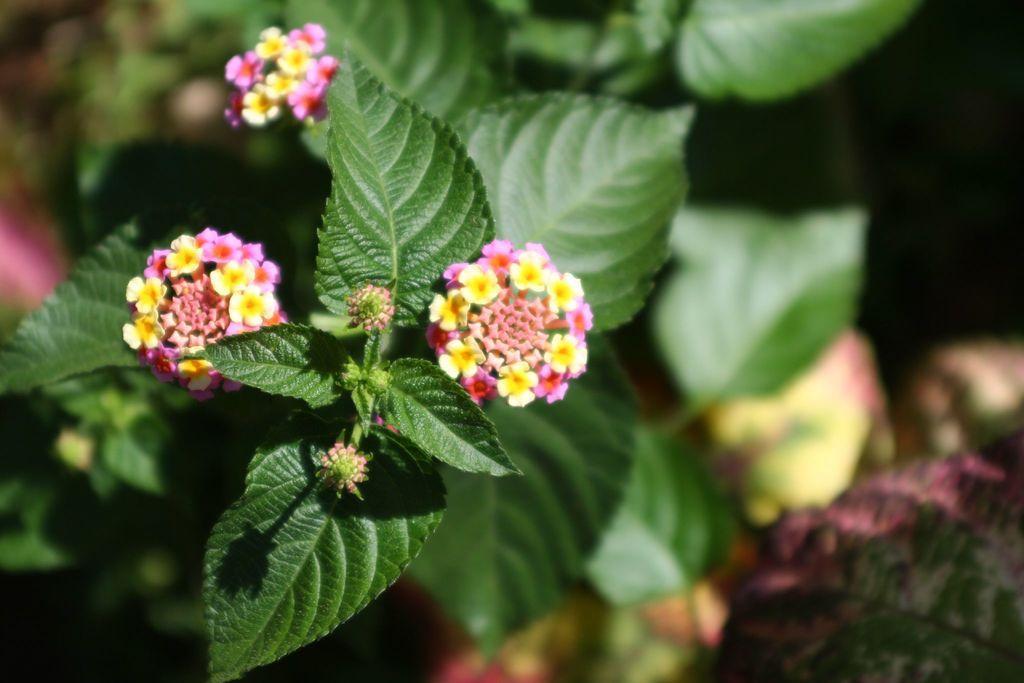How would you summarize this image in a sentence or two? In this picture, we see a plant or a tree. This plant has flower and these flowers are in yellow and pink color. In the background, we see the plants. It is blurred in the background. 